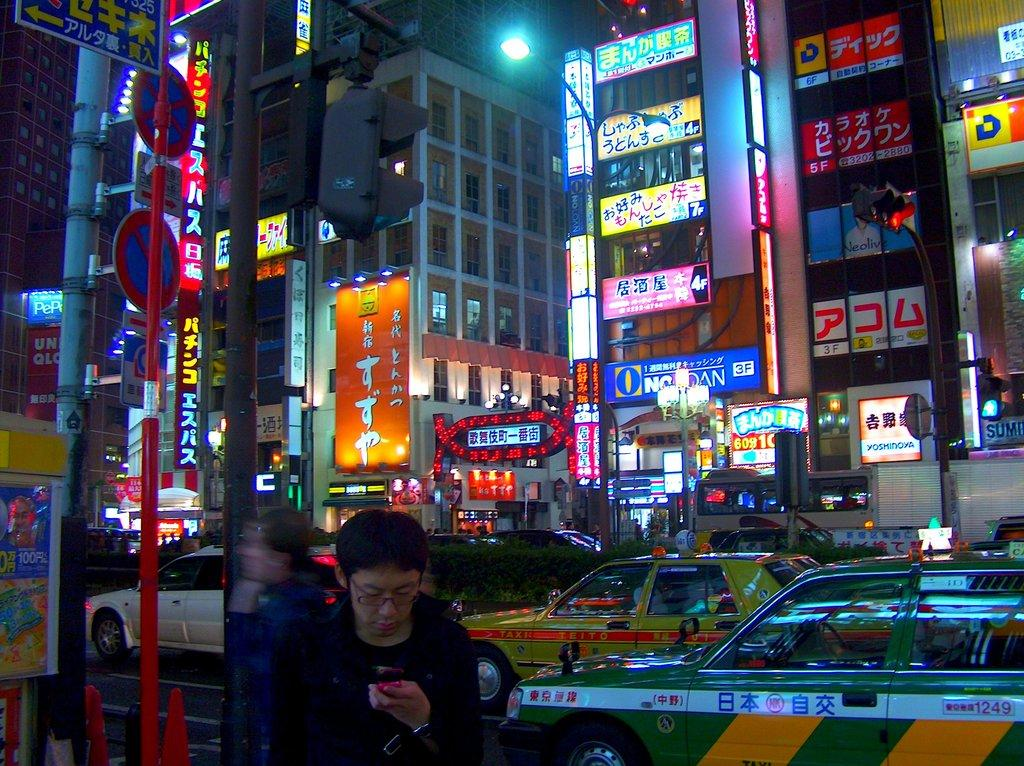<image>
Write a terse but informative summary of the picture. A city street with two taxis and a Yoshinoya across the street. 